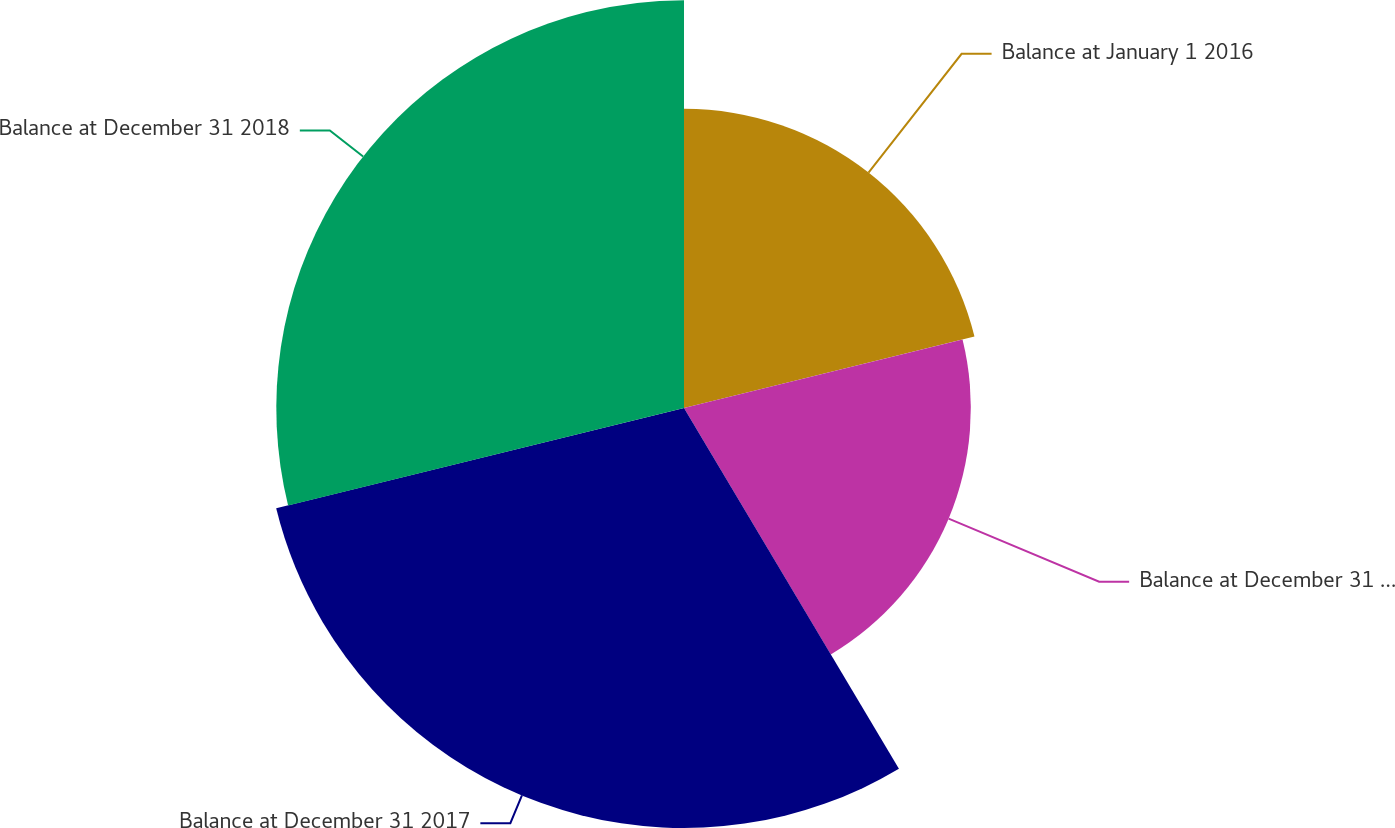Convert chart to OTSL. <chart><loc_0><loc_0><loc_500><loc_500><pie_chart><fcel>Balance at January 1 2016<fcel>Balance at December 31 2016<fcel>Balance at December 31 2017<fcel>Balance at December 31 2018<nl><fcel>21.16%<fcel>20.29%<fcel>29.71%<fcel>28.84%<nl></chart> 